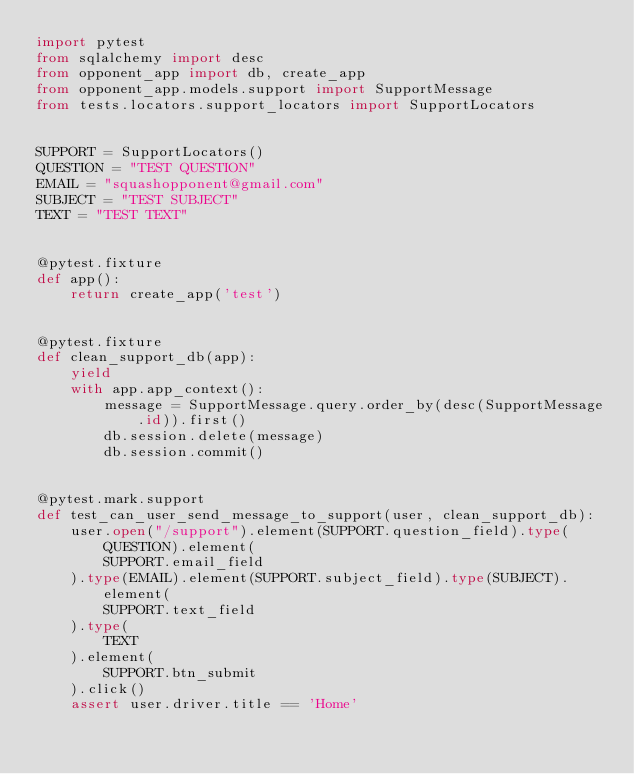<code> <loc_0><loc_0><loc_500><loc_500><_Python_>import pytest
from sqlalchemy import desc
from opponent_app import db, create_app
from opponent_app.models.support import SupportMessage
from tests.locators.support_locators import SupportLocators


SUPPORT = SupportLocators()
QUESTION = "TEST QUESTION"
EMAIL = "squashopponent@gmail.com"
SUBJECT = "TEST SUBJECT"
TEXT = "TEST TEXT"


@pytest.fixture
def app():
    return create_app('test')


@pytest.fixture
def clean_support_db(app):
    yield
    with app.app_context():
        message = SupportMessage.query.order_by(desc(SupportMessage.id)).first()
        db.session.delete(message)
        db.session.commit()


@pytest.mark.support
def test_can_user_send_message_to_support(user, clean_support_db):
    user.open("/support").element(SUPPORT.question_field).type(QUESTION).element(
        SUPPORT.email_field
    ).type(EMAIL).element(SUPPORT.subject_field).type(SUBJECT).element(
        SUPPORT.text_field
    ).type(
        TEXT
    ).element(
        SUPPORT.btn_submit
    ).click()
    assert user.driver.title == 'Home'
</code> 